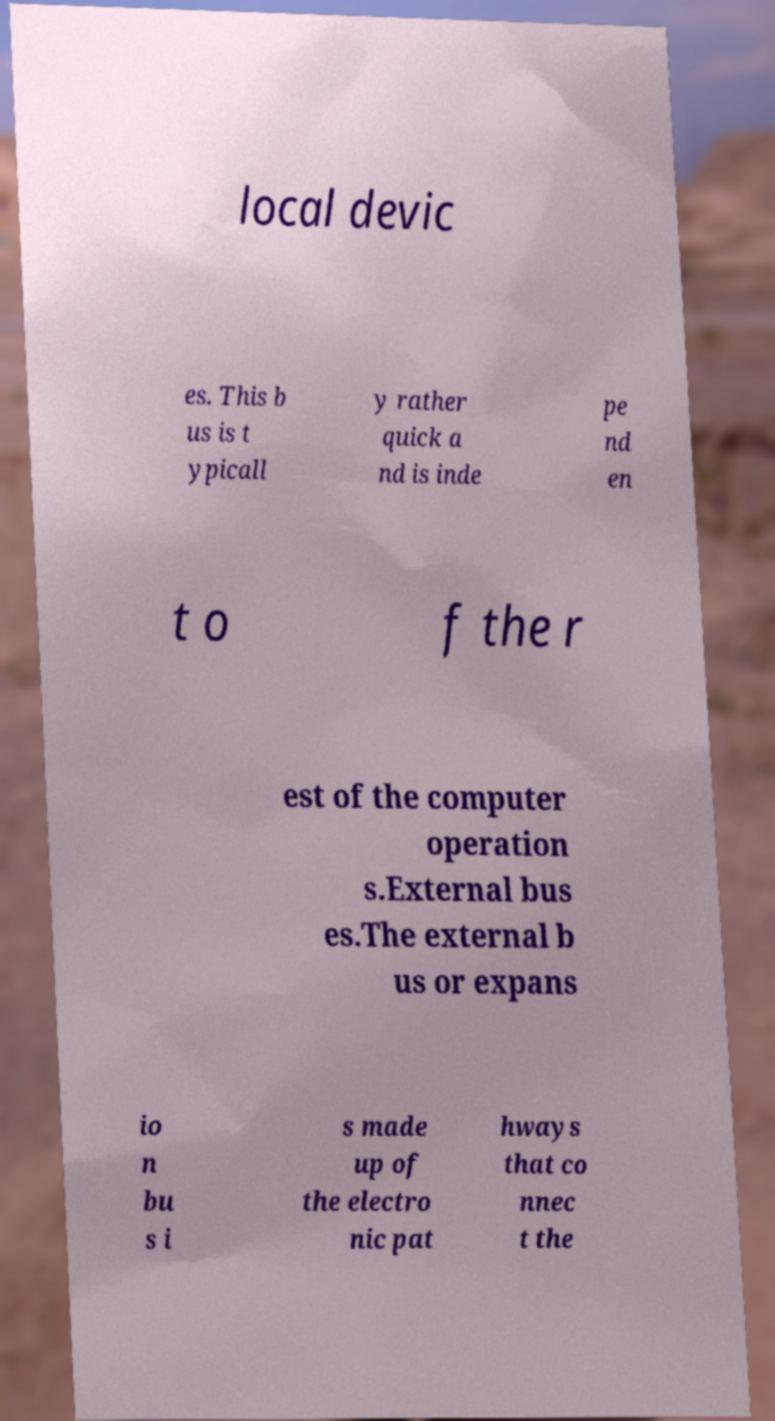Please read and relay the text visible in this image. What does it say? local devic es. This b us is t ypicall y rather quick a nd is inde pe nd en t o f the r est of the computer operation s.External bus es.The external b us or expans io n bu s i s made up of the electro nic pat hways that co nnec t the 